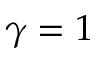<formula> <loc_0><loc_0><loc_500><loc_500>\gamma = 1</formula> 